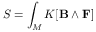Convert formula to latex. <formula><loc_0><loc_0><loc_500><loc_500>S = \int _ { M } K [ B \wedge F ]</formula> 